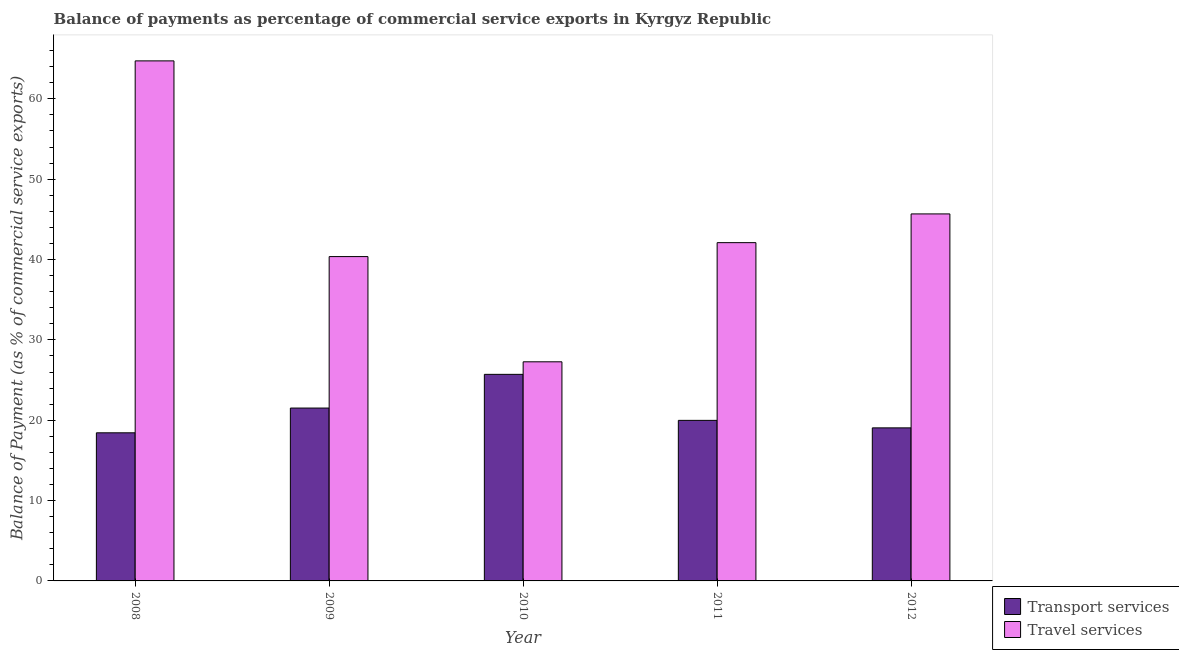How many different coloured bars are there?
Keep it short and to the point. 2. Are the number of bars per tick equal to the number of legend labels?
Offer a terse response. Yes. Are the number of bars on each tick of the X-axis equal?
Keep it short and to the point. Yes. How many bars are there on the 4th tick from the left?
Your answer should be compact. 2. How many bars are there on the 2nd tick from the right?
Offer a very short reply. 2. What is the balance of payments of transport services in 2012?
Provide a succinct answer. 19.05. Across all years, what is the maximum balance of payments of travel services?
Provide a succinct answer. 64.73. Across all years, what is the minimum balance of payments of transport services?
Provide a short and direct response. 18.43. In which year was the balance of payments of transport services maximum?
Offer a terse response. 2010. What is the total balance of payments of travel services in the graph?
Your answer should be compact. 220.15. What is the difference between the balance of payments of travel services in 2008 and that in 2009?
Provide a succinct answer. 24.36. What is the difference between the balance of payments of transport services in 2012 and the balance of payments of travel services in 2010?
Give a very brief answer. -6.66. What is the average balance of payments of transport services per year?
Keep it short and to the point. 20.94. In the year 2008, what is the difference between the balance of payments of travel services and balance of payments of transport services?
Offer a terse response. 0. What is the ratio of the balance of payments of travel services in 2008 to that in 2010?
Give a very brief answer. 2.37. What is the difference between the highest and the second highest balance of payments of transport services?
Offer a very short reply. 4.19. What is the difference between the highest and the lowest balance of payments of transport services?
Make the answer very short. 7.28. Is the sum of the balance of payments of transport services in 2008 and 2010 greater than the maximum balance of payments of travel services across all years?
Keep it short and to the point. Yes. What does the 2nd bar from the left in 2008 represents?
Your response must be concise. Travel services. What does the 1st bar from the right in 2008 represents?
Make the answer very short. Travel services. How many years are there in the graph?
Keep it short and to the point. 5. Where does the legend appear in the graph?
Provide a succinct answer. Bottom right. How many legend labels are there?
Give a very brief answer. 2. What is the title of the graph?
Keep it short and to the point. Balance of payments as percentage of commercial service exports in Kyrgyz Republic. Does "Drinking water services" appear as one of the legend labels in the graph?
Provide a short and direct response. No. What is the label or title of the X-axis?
Your answer should be compact. Year. What is the label or title of the Y-axis?
Provide a succinct answer. Balance of Payment (as % of commercial service exports). What is the Balance of Payment (as % of commercial service exports) in Transport services in 2008?
Offer a very short reply. 18.43. What is the Balance of Payment (as % of commercial service exports) of Travel services in 2008?
Your answer should be compact. 64.73. What is the Balance of Payment (as % of commercial service exports) in Transport services in 2009?
Your response must be concise. 21.52. What is the Balance of Payment (as % of commercial service exports) in Travel services in 2009?
Your response must be concise. 40.37. What is the Balance of Payment (as % of commercial service exports) of Transport services in 2010?
Provide a short and direct response. 25.71. What is the Balance of Payment (as % of commercial service exports) of Travel services in 2010?
Your response must be concise. 27.27. What is the Balance of Payment (as % of commercial service exports) of Transport services in 2011?
Keep it short and to the point. 19.98. What is the Balance of Payment (as % of commercial service exports) of Travel services in 2011?
Your answer should be very brief. 42.1. What is the Balance of Payment (as % of commercial service exports) in Transport services in 2012?
Ensure brevity in your answer.  19.05. What is the Balance of Payment (as % of commercial service exports) of Travel services in 2012?
Give a very brief answer. 45.68. Across all years, what is the maximum Balance of Payment (as % of commercial service exports) of Transport services?
Keep it short and to the point. 25.71. Across all years, what is the maximum Balance of Payment (as % of commercial service exports) in Travel services?
Ensure brevity in your answer.  64.73. Across all years, what is the minimum Balance of Payment (as % of commercial service exports) of Transport services?
Offer a very short reply. 18.43. Across all years, what is the minimum Balance of Payment (as % of commercial service exports) in Travel services?
Make the answer very short. 27.27. What is the total Balance of Payment (as % of commercial service exports) of Transport services in the graph?
Your answer should be very brief. 104.69. What is the total Balance of Payment (as % of commercial service exports) in Travel services in the graph?
Provide a short and direct response. 220.15. What is the difference between the Balance of Payment (as % of commercial service exports) of Transport services in 2008 and that in 2009?
Your answer should be very brief. -3.08. What is the difference between the Balance of Payment (as % of commercial service exports) of Travel services in 2008 and that in 2009?
Provide a short and direct response. 24.36. What is the difference between the Balance of Payment (as % of commercial service exports) in Transport services in 2008 and that in 2010?
Make the answer very short. -7.28. What is the difference between the Balance of Payment (as % of commercial service exports) of Travel services in 2008 and that in 2010?
Provide a short and direct response. 37.46. What is the difference between the Balance of Payment (as % of commercial service exports) of Transport services in 2008 and that in 2011?
Make the answer very short. -1.55. What is the difference between the Balance of Payment (as % of commercial service exports) of Travel services in 2008 and that in 2011?
Ensure brevity in your answer.  22.62. What is the difference between the Balance of Payment (as % of commercial service exports) of Transport services in 2008 and that in 2012?
Provide a succinct answer. -0.61. What is the difference between the Balance of Payment (as % of commercial service exports) of Travel services in 2008 and that in 2012?
Provide a short and direct response. 19.05. What is the difference between the Balance of Payment (as % of commercial service exports) of Transport services in 2009 and that in 2010?
Make the answer very short. -4.19. What is the difference between the Balance of Payment (as % of commercial service exports) in Travel services in 2009 and that in 2010?
Keep it short and to the point. 13.1. What is the difference between the Balance of Payment (as % of commercial service exports) in Transport services in 2009 and that in 2011?
Offer a very short reply. 1.53. What is the difference between the Balance of Payment (as % of commercial service exports) in Travel services in 2009 and that in 2011?
Keep it short and to the point. -1.74. What is the difference between the Balance of Payment (as % of commercial service exports) of Transport services in 2009 and that in 2012?
Ensure brevity in your answer.  2.47. What is the difference between the Balance of Payment (as % of commercial service exports) in Travel services in 2009 and that in 2012?
Your answer should be compact. -5.31. What is the difference between the Balance of Payment (as % of commercial service exports) in Transport services in 2010 and that in 2011?
Offer a terse response. 5.73. What is the difference between the Balance of Payment (as % of commercial service exports) of Travel services in 2010 and that in 2011?
Ensure brevity in your answer.  -14.83. What is the difference between the Balance of Payment (as % of commercial service exports) in Transport services in 2010 and that in 2012?
Give a very brief answer. 6.66. What is the difference between the Balance of Payment (as % of commercial service exports) in Travel services in 2010 and that in 2012?
Offer a very short reply. -18.41. What is the difference between the Balance of Payment (as % of commercial service exports) in Transport services in 2011 and that in 2012?
Give a very brief answer. 0.93. What is the difference between the Balance of Payment (as % of commercial service exports) of Travel services in 2011 and that in 2012?
Your response must be concise. -3.57. What is the difference between the Balance of Payment (as % of commercial service exports) of Transport services in 2008 and the Balance of Payment (as % of commercial service exports) of Travel services in 2009?
Provide a succinct answer. -21.93. What is the difference between the Balance of Payment (as % of commercial service exports) of Transport services in 2008 and the Balance of Payment (as % of commercial service exports) of Travel services in 2010?
Give a very brief answer. -8.84. What is the difference between the Balance of Payment (as % of commercial service exports) in Transport services in 2008 and the Balance of Payment (as % of commercial service exports) in Travel services in 2011?
Give a very brief answer. -23.67. What is the difference between the Balance of Payment (as % of commercial service exports) of Transport services in 2008 and the Balance of Payment (as % of commercial service exports) of Travel services in 2012?
Offer a terse response. -27.24. What is the difference between the Balance of Payment (as % of commercial service exports) in Transport services in 2009 and the Balance of Payment (as % of commercial service exports) in Travel services in 2010?
Offer a terse response. -5.76. What is the difference between the Balance of Payment (as % of commercial service exports) in Transport services in 2009 and the Balance of Payment (as % of commercial service exports) in Travel services in 2011?
Give a very brief answer. -20.59. What is the difference between the Balance of Payment (as % of commercial service exports) of Transport services in 2009 and the Balance of Payment (as % of commercial service exports) of Travel services in 2012?
Provide a succinct answer. -24.16. What is the difference between the Balance of Payment (as % of commercial service exports) of Transport services in 2010 and the Balance of Payment (as % of commercial service exports) of Travel services in 2011?
Make the answer very short. -16.39. What is the difference between the Balance of Payment (as % of commercial service exports) of Transport services in 2010 and the Balance of Payment (as % of commercial service exports) of Travel services in 2012?
Offer a terse response. -19.97. What is the difference between the Balance of Payment (as % of commercial service exports) of Transport services in 2011 and the Balance of Payment (as % of commercial service exports) of Travel services in 2012?
Keep it short and to the point. -25.69. What is the average Balance of Payment (as % of commercial service exports) of Transport services per year?
Your answer should be compact. 20.94. What is the average Balance of Payment (as % of commercial service exports) in Travel services per year?
Give a very brief answer. 44.03. In the year 2008, what is the difference between the Balance of Payment (as % of commercial service exports) in Transport services and Balance of Payment (as % of commercial service exports) in Travel services?
Your answer should be compact. -46.29. In the year 2009, what is the difference between the Balance of Payment (as % of commercial service exports) in Transport services and Balance of Payment (as % of commercial service exports) in Travel services?
Your response must be concise. -18.85. In the year 2010, what is the difference between the Balance of Payment (as % of commercial service exports) of Transport services and Balance of Payment (as % of commercial service exports) of Travel services?
Your response must be concise. -1.56. In the year 2011, what is the difference between the Balance of Payment (as % of commercial service exports) of Transport services and Balance of Payment (as % of commercial service exports) of Travel services?
Keep it short and to the point. -22.12. In the year 2012, what is the difference between the Balance of Payment (as % of commercial service exports) of Transport services and Balance of Payment (as % of commercial service exports) of Travel services?
Ensure brevity in your answer.  -26.63. What is the ratio of the Balance of Payment (as % of commercial service exports) of Transport services in 2008 to that in 2009?
Keep it short and to the point. 0.86. What is the ratio of the Balance of Payment (as % of commercial service exports) in Travel services in 2008 to that in 2009?
Provide a succinct answer. 1.6. What is the ratio of the Balance of Payment (as % of commercial service exports) in Transport services in 2008 to that in 2010?
Offer a very short reply. 0.72. What is the ratio of the Balance of Payment (as % of commercial service exports) in Travel services in 2008 to that in 2010?
Keep it short and to the point. 2.37. What is the ratio of the Balance of Payment (as % of commercial service exports) in Transport services in 2008 to that in 2011?
Keep it short and to the point. 0.92. What is the ratio of the Balance of Payment (as % of commercial service exports) of Travel services in 2008 to that in 2011?
Ensure brevity in your answer.  1.54. What is the ratio of the Balance of Payment (as % of commercial service exports) in Transport services in 2008 to that in 2012?
Your response must be concise. 0.97. What is the ratio of the Balance of Payment (as % of commercial service exports) in Travel services in 2008 to that in 2012?
Your answer should be very brief. 1.42. What is the ratio of the Balance of Payment (as % of commercial service exports) in Transport services in 2009 to that in 2010?
Give a very brief answer. 0.84. What is the ratio of the Balance of Payment (as % of commercial service exports) in Travel services in 2009 to that in 2010?
Give a very brief answer. 1.48. What is the ratio of the Balance of Payment (as % of commercial service exports) of Transport services in 2009 to that in 2011?
Your response must be concise. 1.08. What is the ratio of the Balance of Payment (as % of commercial service exports) of Travel services in 2009 to that in 2011?
Your response must be concise. 0.96. What is the ratio of the Balance of Payment (as % of commercial service exports) of Transport services in 2009 to that in 2012?
Ensure brevity in your answer.  1.13. What is the ratio of the Balance of Payment (as % of commercial service exports) in Travel services in 2009 to that in 2012?
Provide a succinct answer. 0.88. What is the ratio of the Balance of Payment (as % of commercial service exports) in Transport services in 2010 to that in 2011?
Provide a succinct answer. 1.29. What is the ratio of the Balance of Payment (as % of commercial service exports) in Travel services in 2010 to that in 2011?
Your answer should be very brief. 0.65. What is the ratio of the Balance of Payment (as % of commercial service exports) of Transport services in 2010 to that in 2012?
Provide a succinct answer. 1.35. What is the ratio of the Balance of Payment (as % of commercial service exports) of Travel services in 2010 to that in 2012?
Your answer should be compact. 0.6. What is the ratio of the Balance of Payment (as % of commercial service exports) in Transport services in 2011 to that in 2012?
Ensure brevity in your answer.  1.05. What is the ratio of the Balance of Payment (as % of commercial service exports) of Travel services in 2011 to that in 2012?
Your answer should be very brief. 0.92. What is the difference between the highest and the second highest Balance of Payment (as % of commercial service exports) of Transport services?
Give a very brief answer. 4.19. What is the difference between the highest and the second highest Balance of Payment (as % of commercial service exports) of Travel services?
Offer a very short reply. 19.05. What is the difference between the highest and the lowest Balance of Payment (as % of commercial service exports) of Transport services?
Provide a succinct answer. 7.28. What is the difference between the highest and the lowest Balance of Payment (as % of commercial service exports) in Travel services?
Ensure brevity in your answer.  37.46. 